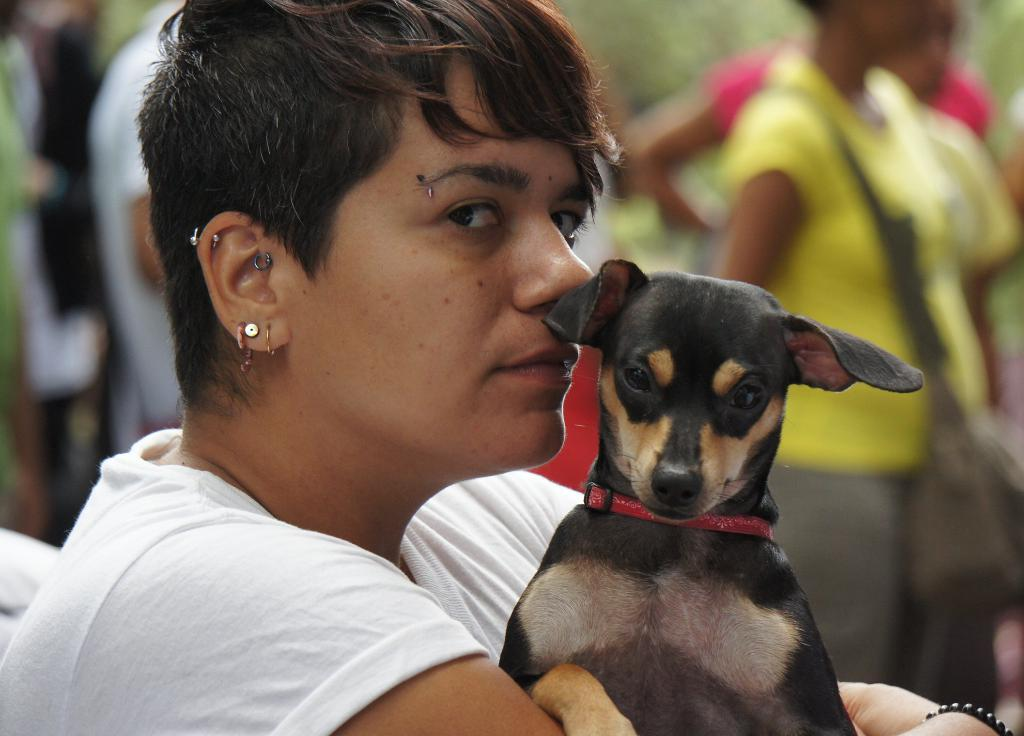What can be observed about the people in the image? There are people in the image, and a woman is holding a dog. What is the woman wearing in the image? The woman is wearing earrings in the image. What are some people in the image carrying? Some people in the image are wearing bags. How many sacks can be seen in the image? There are no sacks present in the image. What is the mass of the head in the image? There is no specific measurement of mass provided in the image, and the concept of mass does not apply to the head in this context. 